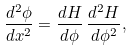<formula> <loc_0><loc_0><loc_500><loc_500>\frac { d ^ { 2 } \phi } { d x ^ { 2 } } = \frac { d H } { d \phi } \, \frac { d ^ { 2 } H } { d \phi ^ { 2 } } ,</formula> 